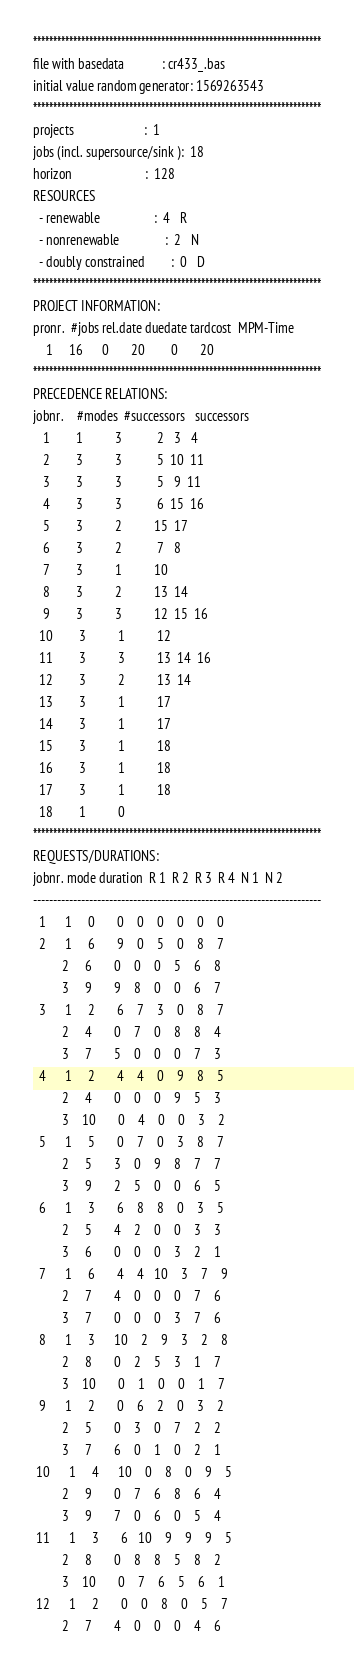Convert code to text. <code><loc_0><loc_0><loc_500><loc_500><_ObjectiveC_>************************************************************************
file with basedata            : cr433_.bas
initial value random generator: 1569263543
************************************************************************
projects                      :  1
jobs (incl. supersource/sink ):  18
horizon                       :  128
RESOURCES
  - renewable                 :  4   R
  - nonrenewable              :  2   N
  - doubly constrained        :  0   D
************************************************************************
PROJECT INFORMATION:
pronr.  #jobs rel.date duedate tardcost  MPM-Time
    1     16      0       20        0       20
************************************************************************
PRECEDENCE RELATIONS:
jobnr.    #modes  #successors   successors
   1        1          3           2   3   4
   2        3          3           5  10  11
   3        3          3           5   9  11
   4        3          3           6  15  16
   5        3          2          15  17
   6        3          2           7   8
   7        3          1          10
   8        3          2          13  14
   9        3          3          12  15  16
  10        3          1          12
  11        3          3          13  14  16
  12        3          2          13  14
  13        3          1          17
  14        3          1          17
  15        3          1          18
  16        3          1          18
  17        3          1          18
  18        1          0        
************************************************************************
REQUESTS/DURATIONS:
jobnr. mode duration  R 1  R 2  R 3  R 4  N 1  N 2
------------------------------------------------------------------------
  1      1     0       0    0    0    0    0    0
  2      1     6       9    0    5    0    8    7
         2     6       0    0    0    5    6    8
         3     9       9    8    0    0    6    7
  3      1     2       6    7    3    0    8    7
         2     4       0    7    0    8    8    4
         3     7       5    0    0    0    7    3
  4      1     2       4    4    0    9    8    5
         2     4       0    0    0    9    5    3
         3    10       0    4    0    0    3    2
  5      1     5       0    7    0    3    8    7
         2     5       3    0    9    8    7    7
         3     9       2    5    0    0    6    5
  6      1     3       6    8    8    0    3    5
         2     5       4    2    0    0    3    3
         3     6       0    0    0    3    2    1
  7      1     6       4    4   10    3    7    9
         2     7       4    0    0    0    7    6
         3     7       0    0    0    3    7    6
  8      1     3      10    2    9    3    2    8
         2     8       0    2    5    3    1    7
         3    10       0    1    0    0    1    7
  9      1     2       0    6    2    0    3    2
         2     5       0    3    0    7    2    2
         3     7       6    0    1    0    2    1
 10      1     4      10    0    8    0    9    5
         2     9       0    7    6    8    6    4
         3     9       7    0    6    0    5    4
 11      1     3       6   10    9    9    9    5
         2     8       0    8    8    5    8    2
         3    10       0    7    6    5    6    1
 12      1     2       0    0    8    0    5    7
         2     7       4    0    0    0    4    6</code> 